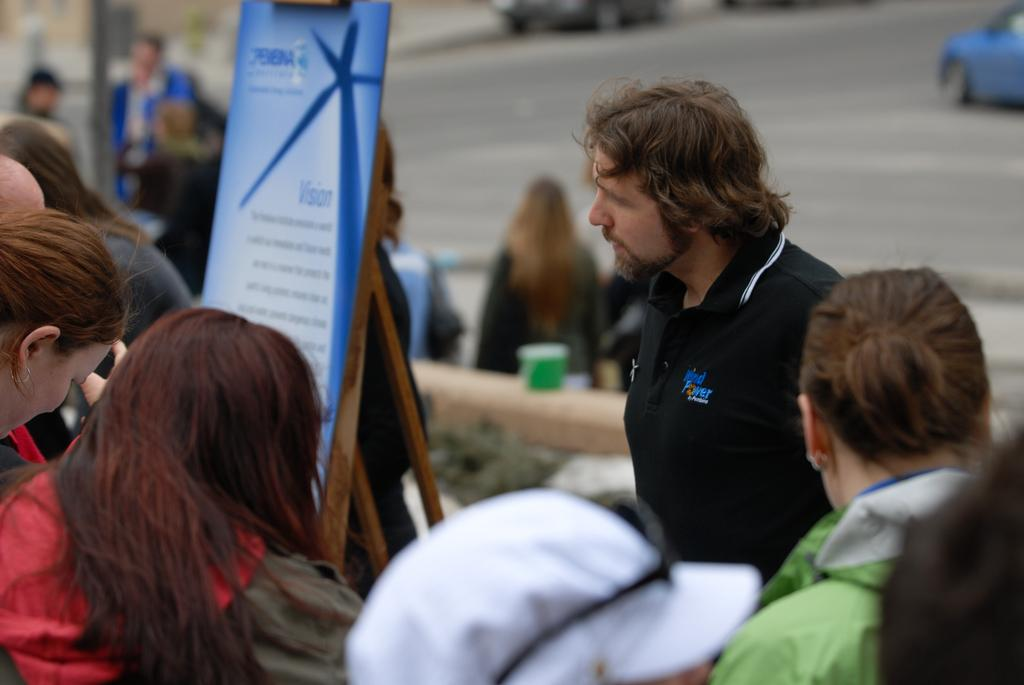What can be seen in the image involving people? There are people standing in the image. What is the board with text used for in the image? The board with text is likely used for communication or displaying information. What is happening with the car in the image? A car is moving on the road in the image. Where is the cup located in the image? The cup is on the wall in the image. What type of hammer is being used by the people in the image? There is no hammer present in the image; the people are standing and there is a board with text and a moving car on the road. 